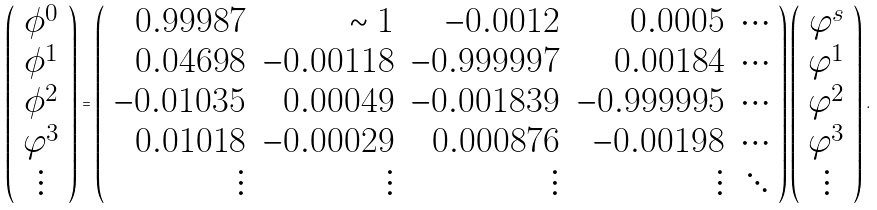<formula> <loc_0><loc_0><loc_500><loc_500>\left ( \begin{array} { c } \phi ^ { 0 } \\ \phi ^ { 1 } \\ \phi ^ { 2 } \\ \varphi ^ { 3 } \\ \vdots \end{array} \right ) = \left ( \begin{array} { r r r r r } 0 . 9 9 9 8 7 & \sim 1 & - 0 . 0 0 1 2 & 0 . 0 0 0 5 & \cdots \\ 0 . 0 4 6 9 8 & - 0 . 0 0 1 1 8 & - 0 . 9 9 9 9 9 7 & 0 . 0 0 1 8 4 & \cdots \\ - 0 . 0 1 0 3 5 & 0 . 0 0 0 4 9 & - 0 . 0 0 1 8 3 9 & - 0 . 9 9 9 9 9 5 & \cdots \\ 0 . 0 1 0 1 8 & - 0 . 0 0 0 2 9 & 0 . 0 0 0 8 7 6 & - 0 . 0 0 1 9 8 & \cdots \\ \vdots & \vdots & \vdots & \vdots & \ddots \end{array} \right ) \left ( \begin{array} { c } \varphi ^ { s } \\ \varphi ^ { 1 } \\ \varphi ^ { 2 } \\ \varphi ^ { 3 } \\ \vdots \end{array} \right ) .</formula> 